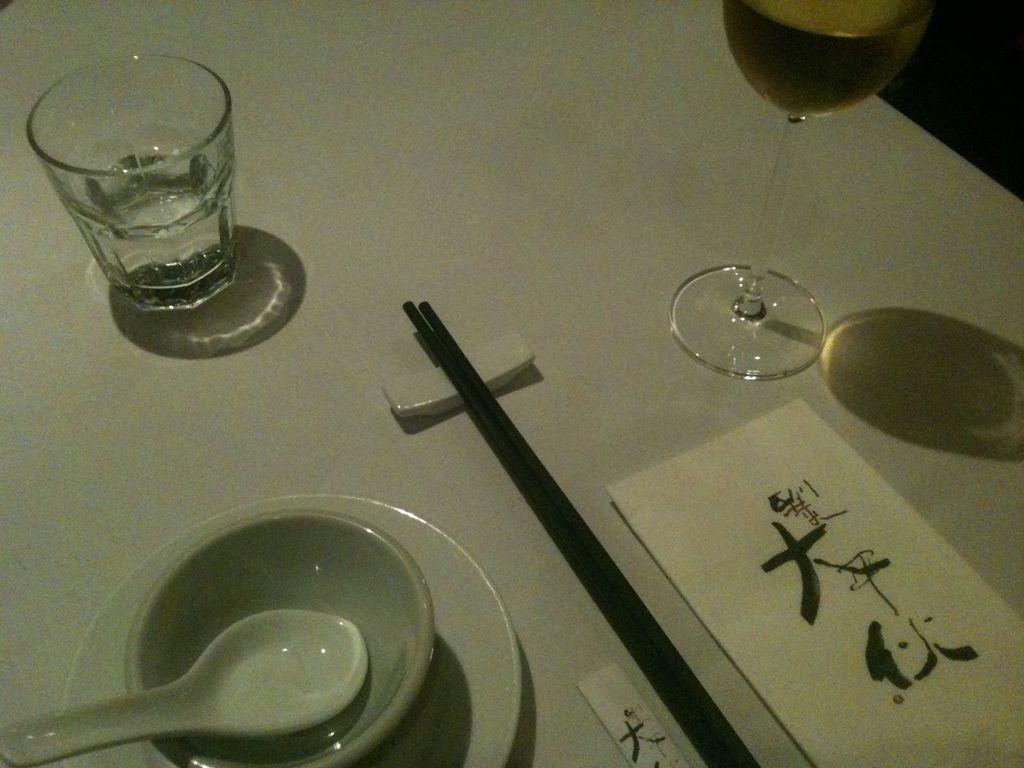What is on the table in the image? There is a glass, a cup, a spoon, chopsticks, and a napkin on the table in the image. What type of utensils are present on the table? There is a spoon and chopsticks on the table. What might be used for wiping or drying in the image? A napkin is present on the table for wiping or drying. What type of office equipment can be seen on the table in the image? There is no office equipment present on the table in the image. How much salt is visible on the table in the image? There is no salt visible on the table in the image. 